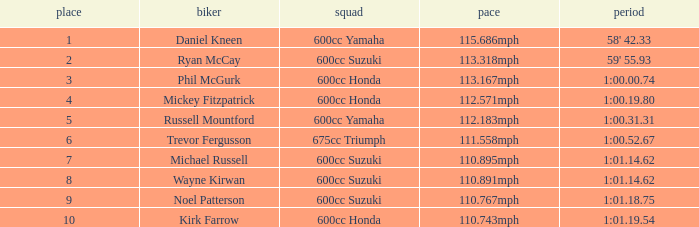How many ranks have 1:01.14.62 as the time, with michael russell as the rider? 1.0. 